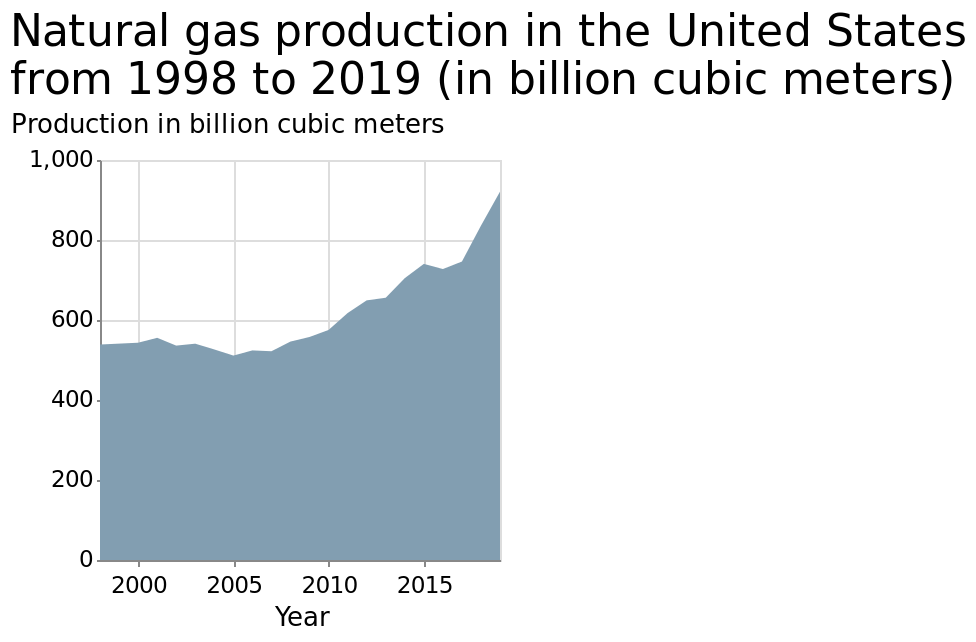<image>
How would you describe the trend in natural gas production from 1998 to 2005? The trend in natural gas production from 1998 to 2005 was fairly steady. What is the time period represented in the area plot?  The area plot represents the natural gas production in the United States from 1998 to 2019. What is the title of the area plot?  The title of the area plot is "Natural gas production in the United States from 1998 to 2019 (in billion cubic meters)." 